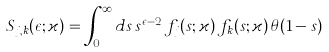Convert formula to latex. <formula><loc_0><loc_0><loc_500><loc_500>S _ { j , k } ( \epsilon ; \varkappa ) = \int _ { 0 } ^ { \infty } d s \, s ^ { \epsilon - 2 } \, f _ { j } ( s ; \varkappa ) \, f _ { k } ( s ; \varkappa ) \, \theta ( 1 - s )</formula> 